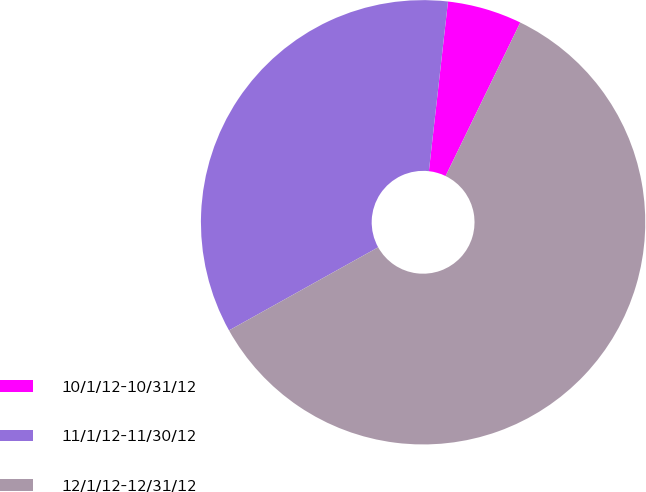Convert chart. <chart><loc_0><loc_0><loc_500><loc_500><pie_chart><fcel>10/1/12-10/31/12<fcel>11/1/12-11/30/12<fcel>12/1/12-12/31/12<nl><fcel>5.42%<fcel>34.88%<fcel>59.71%<nl></chart> 